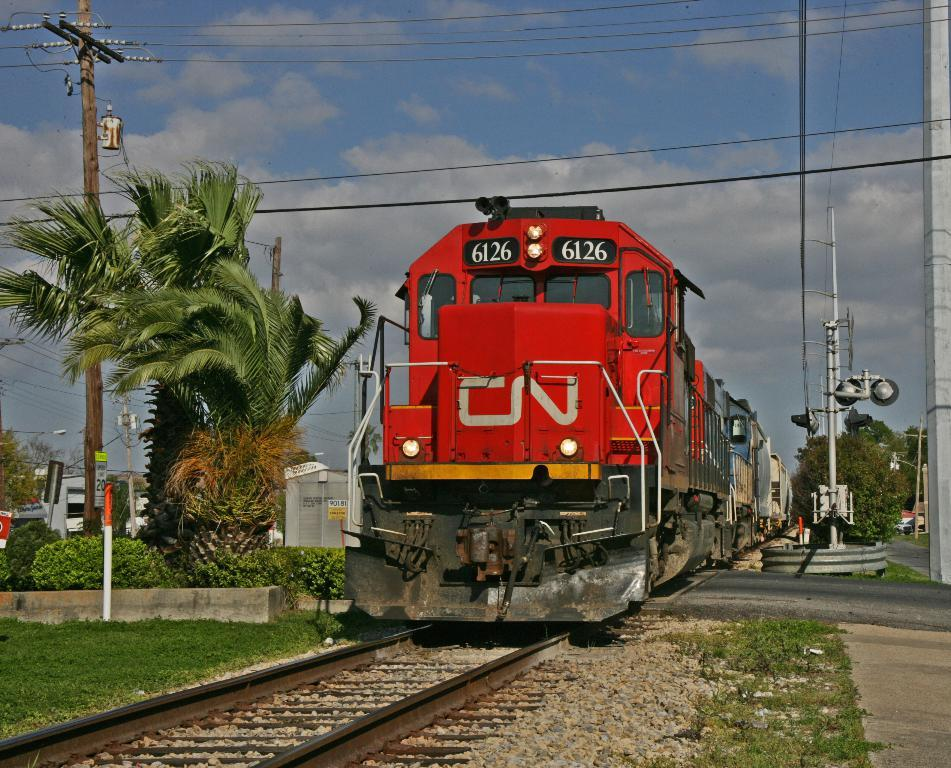What is the main subject of the image? The main subject of the image is a train on the railway track. What type of vegetation can be seen in the image? There are trees, plants, and grass visible in the image. What structures can be seen in the image? There are poles visible in the image. What is visible in the background of the image? The sky is visible in the background of the image. How many cars are parked near the train in the image? There are no cars present in the image; it features a train on a railway track with vegetation and poles in the background. What type of cannon is being used by the carpenter in the image? There is no carpenter or cannon present in the image. 